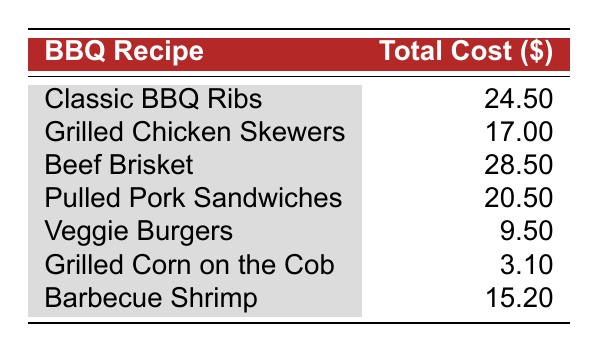What is the total cost of Classic BBQ Ribs? The total cost is provided directly in the table under the 'Total Cost ($)' column corresponding to the 'Classic BBQ Ribs' recipe. The figure is 24.50.
Answer: 24.50 Which barbecue recipe has the highest total cost? By reviewing the 'Total Cost ($)' column, the recipe 'Beef Brisket' has the highest cost listed, which is 28.50.
Answer: Beef Brisket What is the total cost of the Veggie Burgers and Grilled Corn on the Cob combined? The cost of Veggie Burgers is 9.50 and Grilled Corn on the Cob is 3.10. Adding these together: 9.50 + 3.10 = 12.60.
Answer: 12.60 Is the total cost of Pulled Pork Sandwiches greater than 20 dollars? Checking the total cost listed for Pulled Pork Sandwiches, we see it is 20.50, which is greater than 20. Therefore, the answer is yes.
Answer: Yes What is the average total cost of the barbecue recipes listed? First, the total costs are: 24.50, 17.00, 28.50, 20.50, 9.50, 3.10, and 15.20. The sum of these values is 118.20. There are 7 recipes, so the average is 118.20 / 7 = 16.74.
Answer: 16.74 Which recipe has a total cost that is less than 10 dollars? By scanning the table, we see that the 'Veggie Burgers' cost 9.50, which is less than 10 dollars.
Answer: Veggie Burgers What is the cost difference between the Beef Brisket and the Classic BBQ Ribs? The total cost of Beef Brisket is 28.50 and for Classic BBQ Ribs it's 24.50. Therefore, the difference is 28.50 - 24.50 = 4.00.
Answer: 4.00 Is BBQ sauce an ingredient in both Classic BBQ Ribs and Pulled Pork Sandwiches? Yes, reviewing the ingredients for both recipes, BBQ sauce is listed as an ingredient in each, confirming the statement is true.
Answer: Yes How much do the ingredients for Barbecue Shrimp cost in total? The total cost is directly available in the table under Barbecue Shrimp, which sums up to 15.20.
Answer: 15.20 